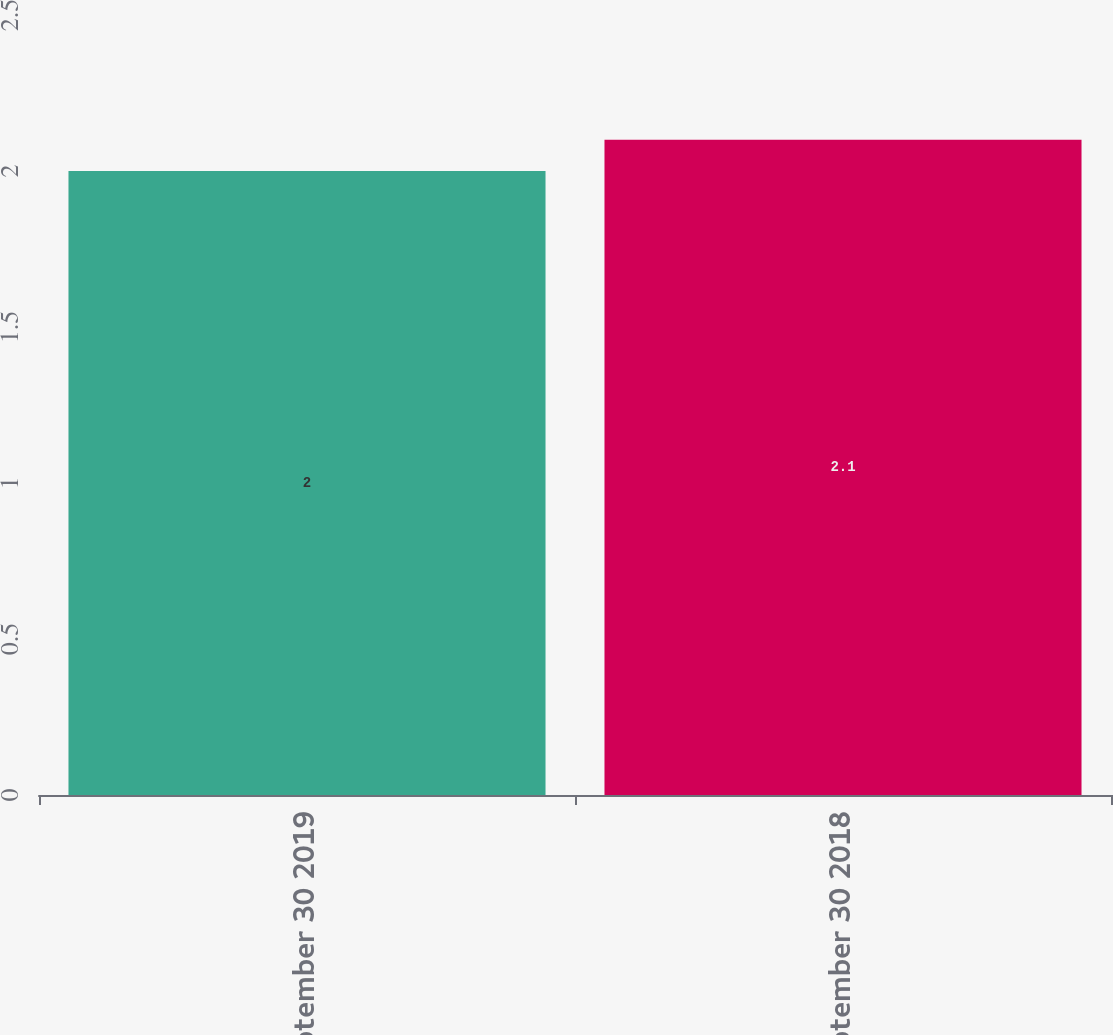Convert chart to OTSL. <chart><loc_0><loc_0><loc_500><loc_500><bar_chart><fcel>September 30 2019<fcel>September 30 2018<nl><fcel>2<fcel>2.1<nl></chart> 